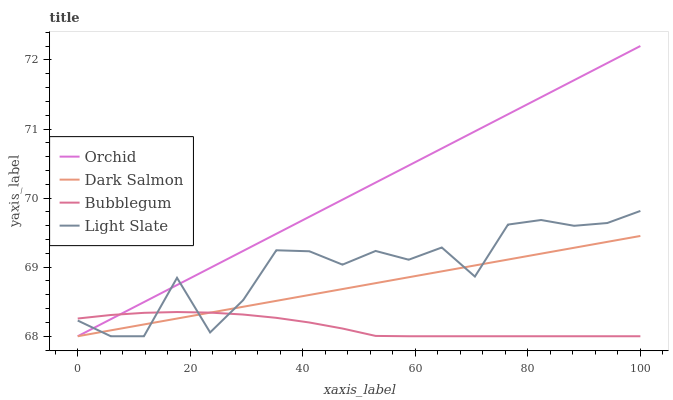Does Bubblegum have the minimum area under the curve?
Answer yes or no. Yes. Does Orchid have the maximum area under the curve?
Answer yes or no. Yes. Does Dark Salmon have the minimum area under the curve?
Answer yes or no. No. Does Dark Salmon have the maximum area under the curve?
Answer yes or no. No. Is Orchid the smoothest?
Answer yes or no. Yes. Is Light Slate the roughest?
Answer yes or no. Yes. Is Dark Salmon the smoothest?
Answer yes or no. No. Is Dark Salmon the roughest?
Answer yes or no. No. Does Orchid have the highest value?
Answer yes or no. Yes. Does Dark Salmon have the highest value?
Answer yes or no. No. 